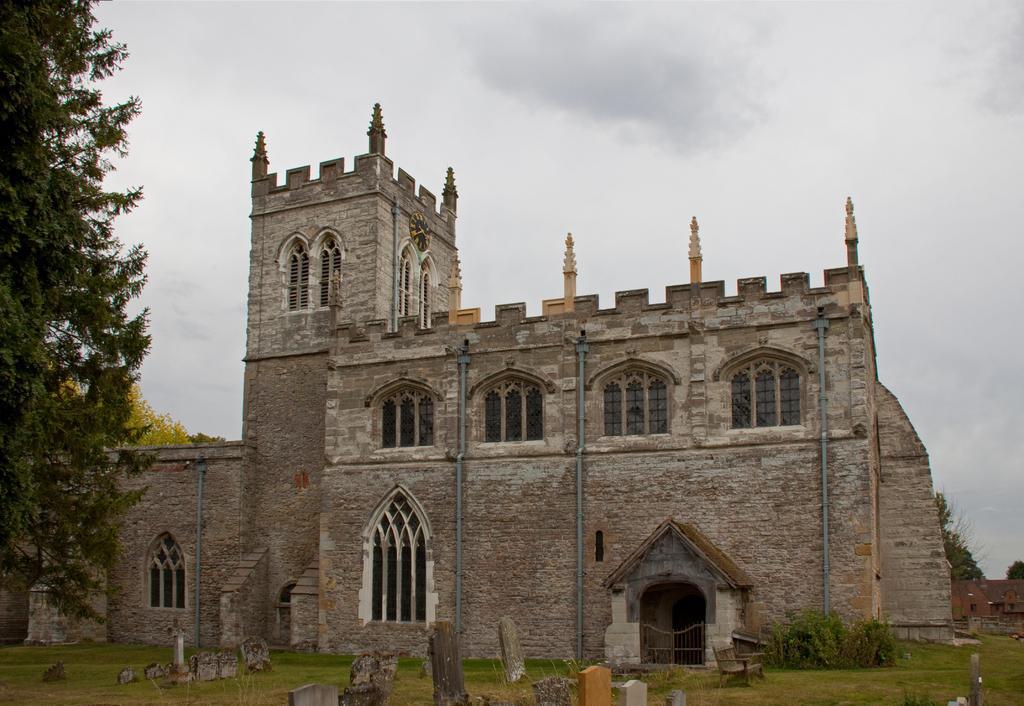Please provide a concise description of this image. In the center of the image there is a building with windows. At the bottom of the image there is grass. To the left side of the image there are trees. At the top of the image there is sky. 